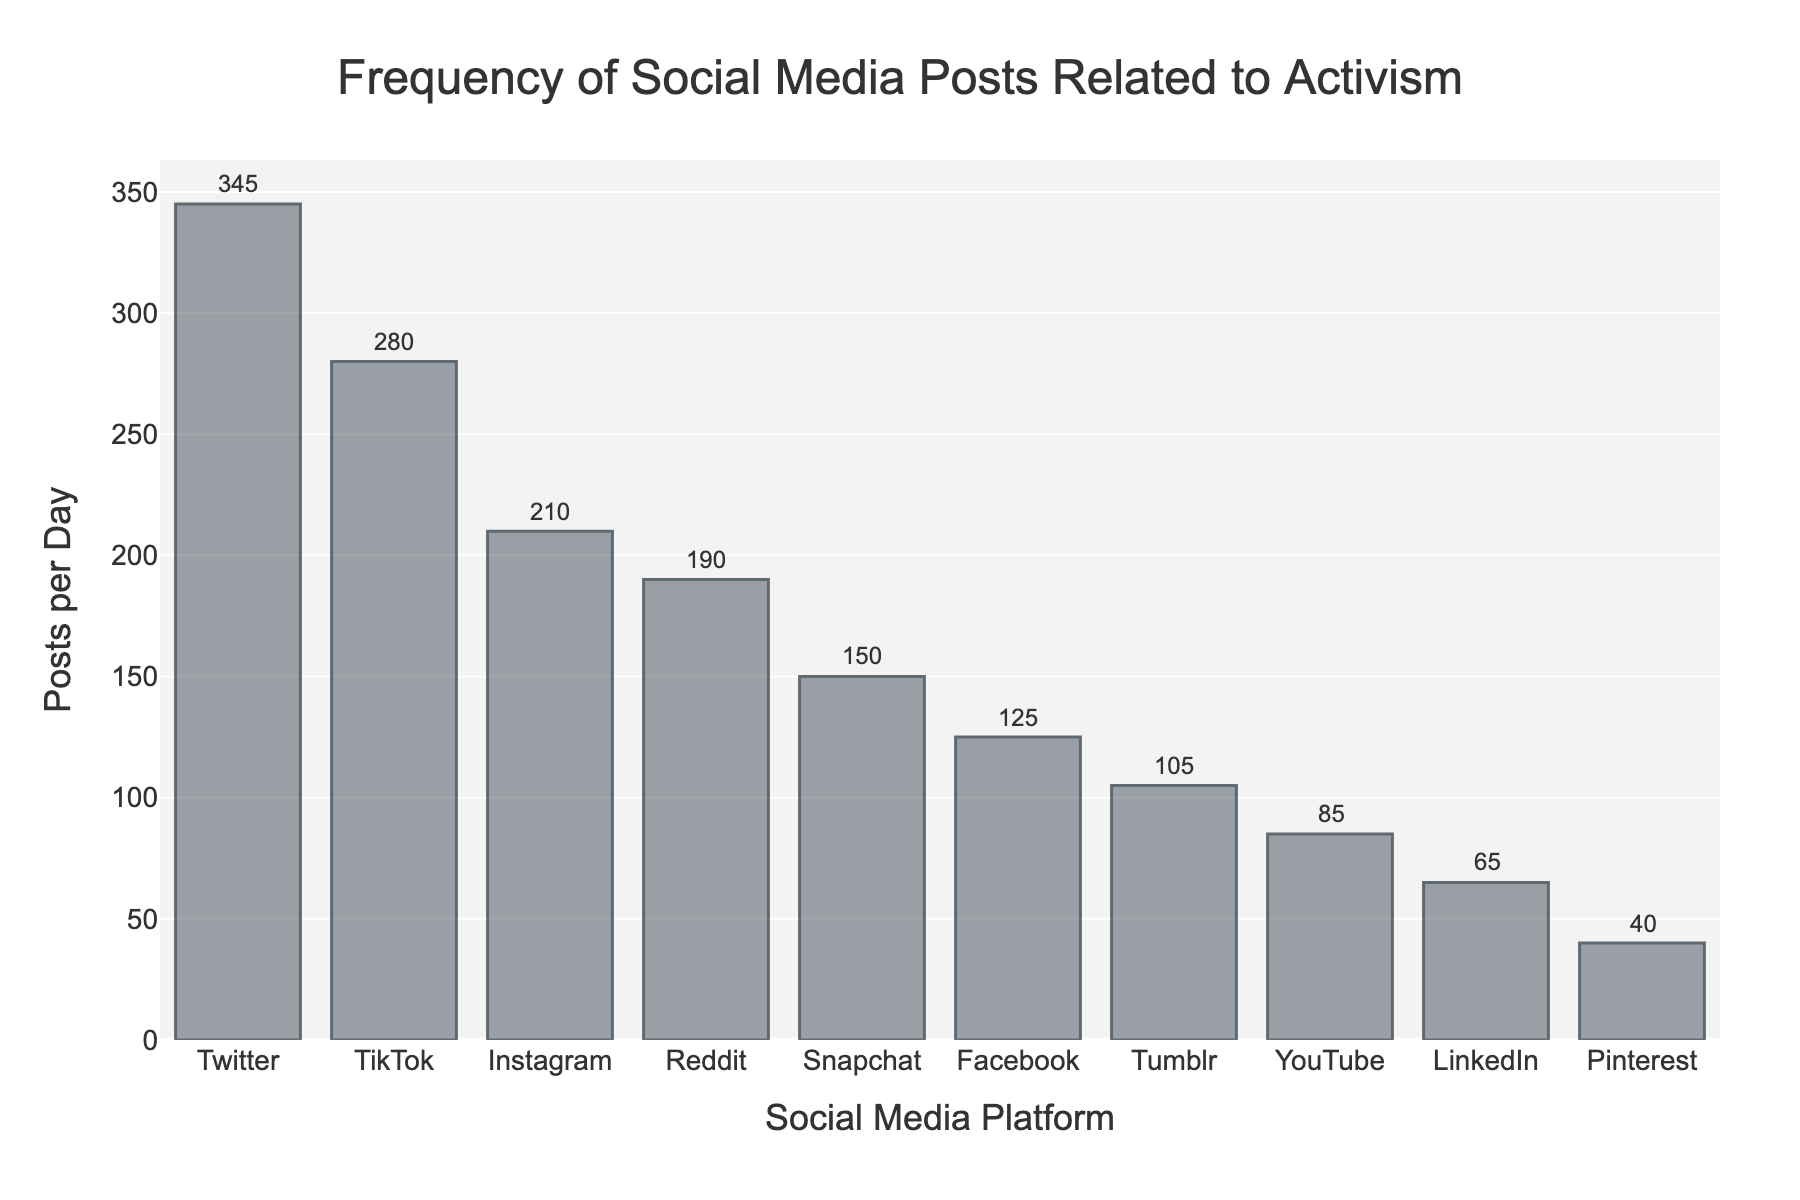Which social media platform has the highest number of posts related to activism per day? The platform with the highest bar and the largest numerical annotation indicates the highest number of posts. Here, Twitter has the highest value with 345 posts per day.
Answer: Twitter What's the range of posts per day across all social media platforms represented? To find the range, subtract the smallest value (Pinterest, 40 posts) from the largest value (Twitter, 345 posts). The range is 345 - 40 = 305.
Answer: 305 How many platforms have more than 200 posts per day? Count the number of bars with values greater than 200. Here, Twitter (345), TikTok (280), and Instagram (210) meet this criterion. There are 3 platforms.
Answer: 3 Which platforms have fewer than 100 posts per day? Examine the bars and their annotations for values below 100. LinkedIn (65), YouTube (85), and Pinterest (40) are below 100 posts.
Answer: LinkedIn, YouTube, Pinterest What is the average number of posts per day for the platforms listed? Sum all the posts per day values and divide by the number of platforms. Total posts: 125 + 345 + 210 + 280 + 65 + 190 + 85 + 105 + 40 + 150 = 1595. Number of platforms: 10. Average = 1595/10 = 159.5.
Answer: 159.5 How do Facebook and Snapchat compare in terms of posts per day? Look at the bars for Facebook (125 posts) and Snapchat (150 posts). Snapchat has 25 more posts per day than Facebook.
Answer: Snapchat has 25 more posts per day than Facebook What total combined posts per day do Instagram, TikTok, and Reddit have together? Sum the posts per day of Instagram (210), TikTok (280), and Reddit (190). The combined total is 210 + 280 + 190 = 680.
Answer: 680 Is there more activism-related posting on Twitter alone than on Reddit and LinkedIn combined? Compare the posts on Twitter (345) with the combined posts on Reddit (190) and LinkedIn (65). Combined Reddit and LinkedIn = 190 + 65 = 255. Twitter has more since 345 > 255.
Answer: Yes, Twitter has more Between YouTube and Tumblr, which platform has a closer number of posts to LinkedIn? Look at the posts per day for YouTube (85), Tumblr (105), and LinkedIn (65). Calculate the absolute differences: YouTube to LinkedIn = 85 - 65 = 20, Tumblr to LinkedIn = 105 - 65 = 40. YouTube is closer to LinkedIn than Tumblr.
Answer: YouTube What's the median number of posts per day among the platforms? Order the posts per day values: [40, 65, 85, 105, 125, 150, 190, 210, 280, 345]. The median is the average of the 5th and 6th values: (125 + 150)/2 = 137.5.
Answer: 137.5 